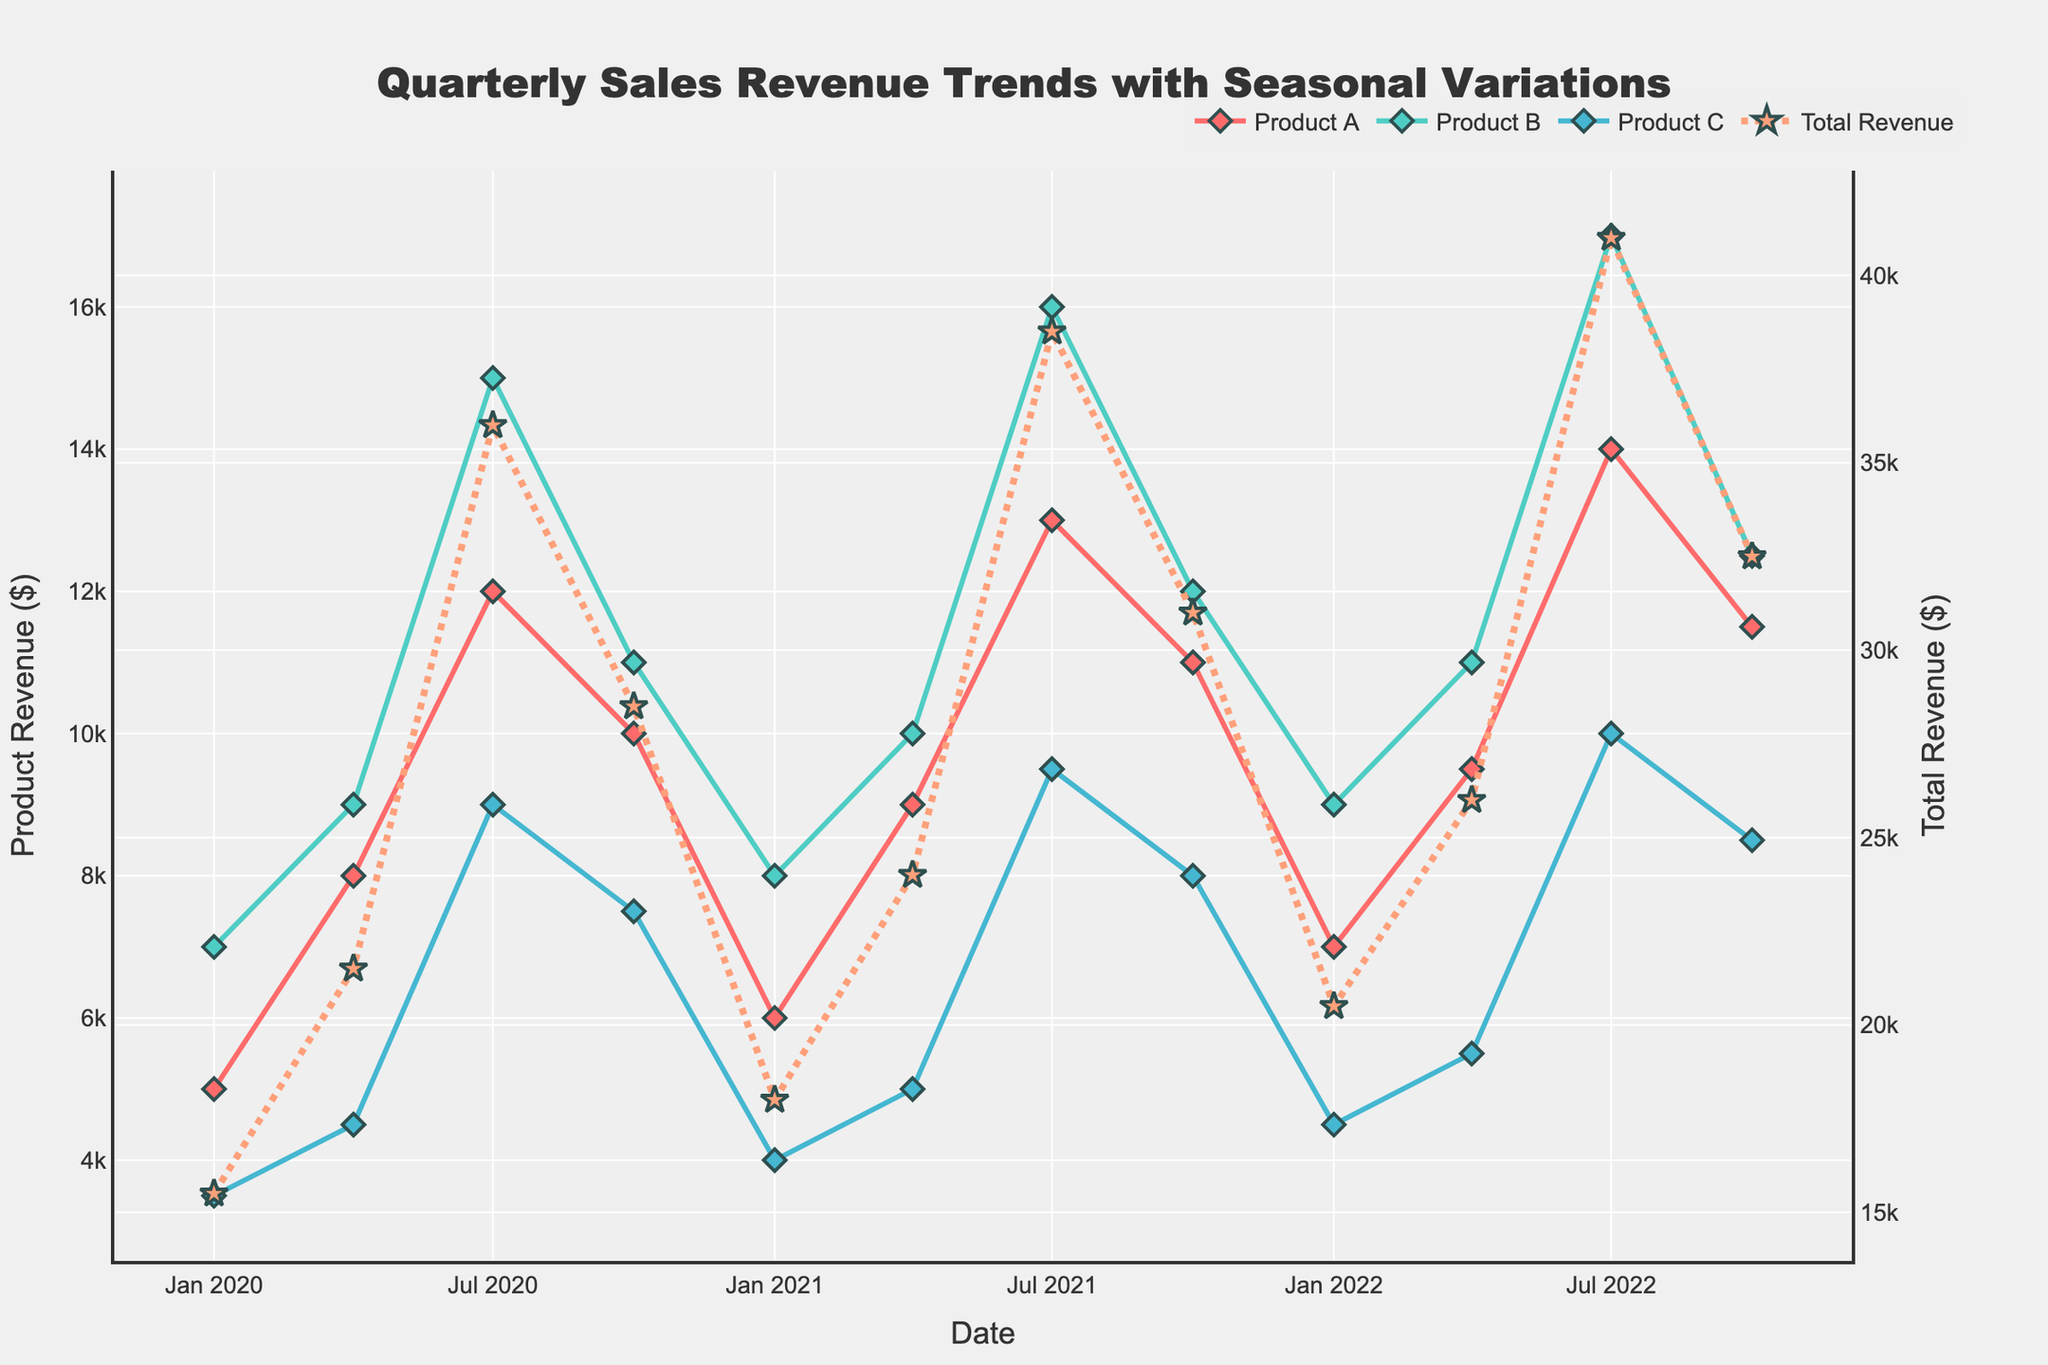what's the title of the plot? The title of the plot is located at the top and is meant to describe what the plot visualizes. The title of this specific plot reads "Quarterly Sales Revenue Trends with Seasonal Variations," which gives us an understanding that we're seeing quarterly data with a focus on seasonal changes.
Answer: Quarterly Sales Revenue Trends with Seasonal Variations what is the y-axis title for the secondary y-axis? The secondary y-axis title is visible on the right-hand side of the plot and describes what the right y-axis measures. In this case, the title is "Total Revenue ($)," which indicates that the secondary y-axis is measuring the total revenue in dollars.
Answer: Total Revenue ($) what color represents Product A? In the plot, each product is represented using a distinct color for clarity. Product A is represented by a bold red color, which makes it easily distinguishable from other product lines.
Answer: Red what was the total revenue in Q3 of 2020? To find the total revenue in the third quarter of 2020, look at the highlighted total revenue line (dotted line) in Q3 2020 data point. By checking the y-coordinate value of the dotted line in Q3 2020 (around July 2020), we can see that the total revenue is approximately $36,000.
Answer: $36,000 which product had the lowest sales revenue in Q1 of 2021? For Q1 2021, locate the January 2021 data points and compare the values for each product. Product C had the lowest sales revenue at approximately $4,000 among all three products.
Answer: Product C how did Product B's revenue change from Q1 to Q3 in 2021? By comparing Product B's revenue point in Q1 2021 (January) to Q3 2021 (July), we can find that the revenue increased from $8,000 to $16,000. So, the revenue doubled through this two-quarter span.
Answer: It doubled how does the total revenue in Q4 of 2022 compare to Q1 of 2020? To compare the total revenue between Q4 of 2022 (October 2022) and Q1 of 2020 (January 2020), note the values of the dotted line at those points. Q4 of 2022 shows around $32,500, while Q1 of 2020 shows around $15,500, so Q4 2022 is significantly higher than Q1 2020.
Answer: Q4 2022 is higher which quarter shows the highest spike in total revenue? To figure out the highest spike, look for the highest point on the dotted line representing total revenue. The most significant peak is seen in Q3 2022 (July 2022) with total revenue approximately around $41,000.
Answer: Q3 2022 how did the seasonal variation affect Product C's revenue over the three years? Noticeably, Product C's revenue shows regular patterns, with peaks typically occurring in the third quarter (July), and lower points in the first quarter (January). This seasonal trend is consistent over the three years, highlighting the seasonal variation impact on sales performance.
Answer: Peaks in Q3, lower in Q1 